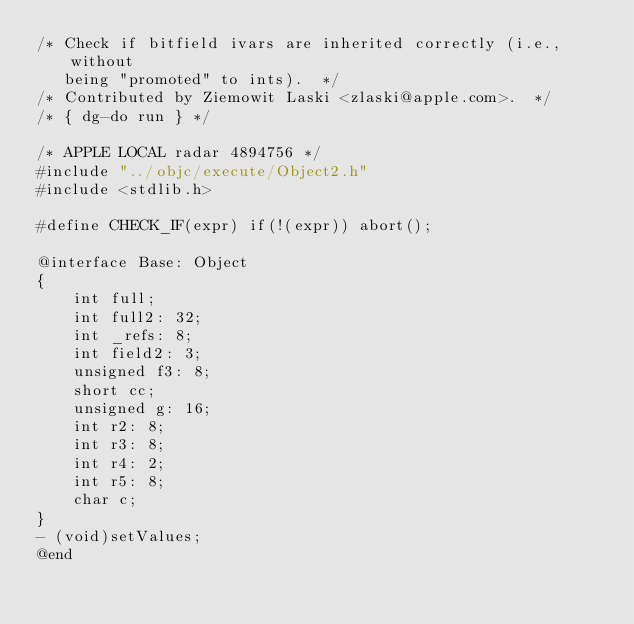<code> <loc_0><loc_0><loc_500><loc_500><_ObjectiveC_>/* Check if bitfield ivars are inherited correctly (i.e., without
   being "promoted" to ints).  */
/* Contributed by Ziemowit Laski <zlaski@apple.com>.  */
/* { dg-do run } */

/* APPLE LOCAL radar 4894756 */
#include "../objc/execute/Object2.h"
#include <stdlib.h>

#define CHECK_IF(expr) if(!(expr)) abort();

@interface Base: Object 
{
    int full;
    int full2: 32;
    int _refs: 8;
    int field2: 3;
    unsigned f3: 8;
    short cc;
    unsigned g: 16;
    int r2: 8;
    int r3: 8;
    int r4: 2;
    int r5: 8;
    char c;
}
- (void)setValues;
@end
</code> 